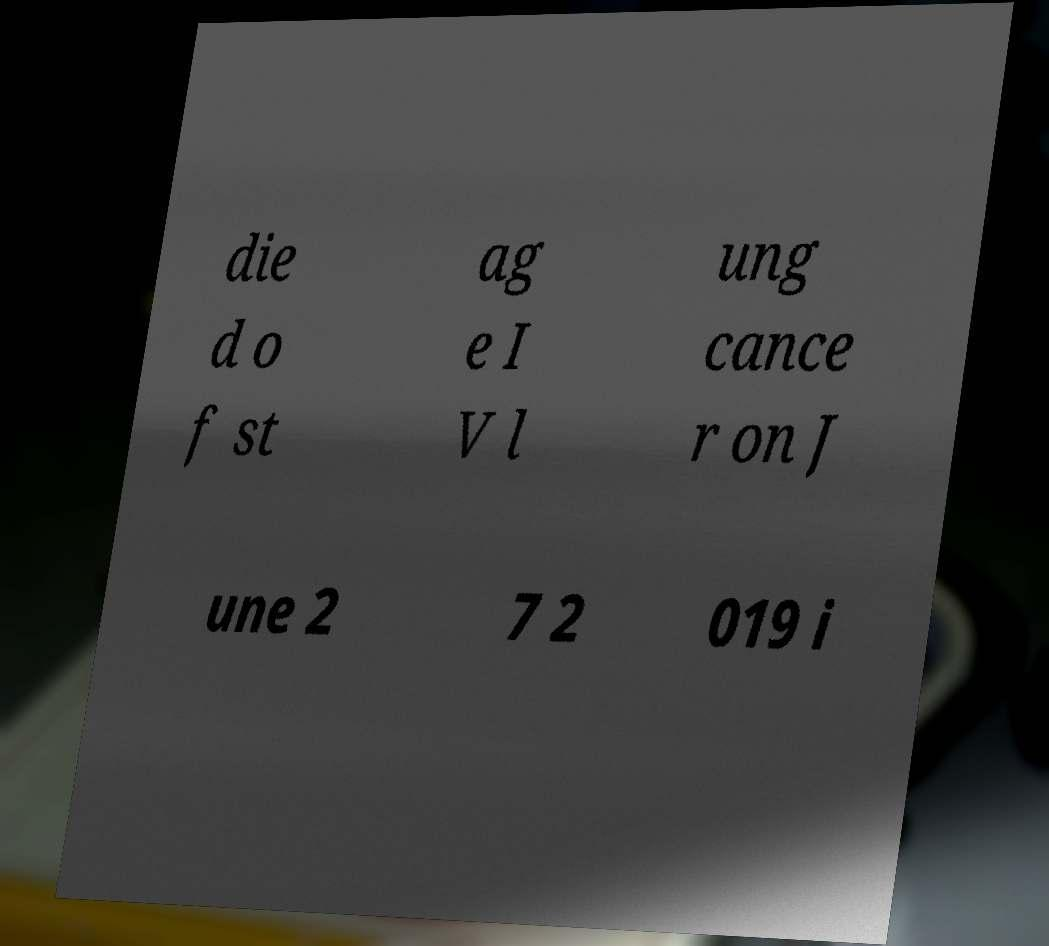Can you accurately transcribe the text from the provided image for me? die d o f st ag e I V l ung cance r on J une 2 7 2 019 i 